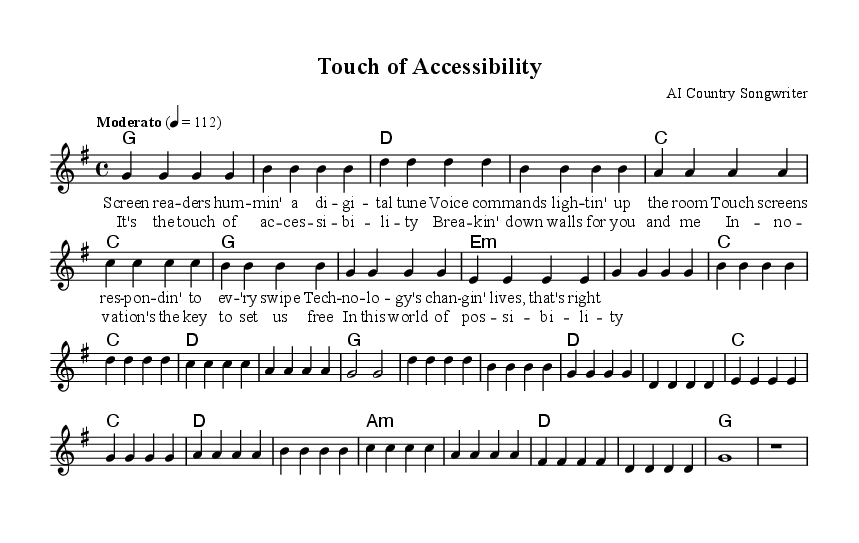What is the key signature of this music? The key signature can be identified from the `\key` command in the global block, which indicates G major. G major has one sharp, which is F#.
Answer: G major What is the time signature of this piece? The time signature is shown in the `\time` command within the global block. It reads 4/4, indicating four beats per measure.
Answer: 4/4 What is the tempo marking for the piece? The tempo is specified in the `\tempo` command; it indicates a moderato pace of 112 beats per minute.
Answer: Moderato 112 How many measures are in the verse section? The verse contains a total of eight measures, which can be counted by analyzing the melody section and considering its structure.
Answer: 8 What is the first lyric line of the chorus? The first lyric line of the chorus is indicated directly in the `\lyricmode` section under the chorus definition, which starts with "It's the touch of ac".
Answer: It's the touch of accessibility Which chord is played during the second measure of the verse? The harmony section shows the chord progression where the second measure features a G chord, as seen in the `\harmonies` block.
Answer: G How many lines of lyrics are there in total for the piece? By reviewing both the verse and chorus sections in the `\lyricmode`, we can see there are a total of eight lines of lyrics (four in the verse and four in the chorus).
Answer: 8 